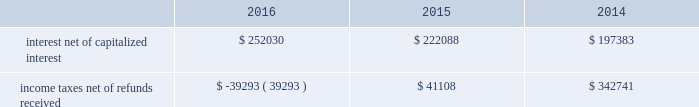The diluted earnings per share calculation excludes stock options , sars , restricted stock and units and performance units and stock that were anti-dilutive .
Shares underlying the excluded stock options and sars totaled 10.3 million , 10.2 million and 0.7 million for the years ended december 31 , 2016 , 2015 and 2014 , respectively .
For the years ended december 31 , 2016 and 2015 , respectively , 4.5 million and 5.3 million shares of restricted stock and restricted stock units and performance units and performance stock were excluded .
10 .
Supplemental cash flow information net cash paid for interest and income taxes was as follows for the years ended december 31 , 2016 , 2015 and 2014 ( in thousands ) : .
Eog's accrued capital expenditures at december 31 , 2016 , 2015 and 2014 were $ 388 million , $ 416 million and $ 972 million , respectively .
Non-cash investing activities for the year ended december 31 , 2016 , included $ 3834 million in non-cash additions to eog's oil and gas properties related to the yates transaction ( see note 17 ) .
Non-cash investing activities for the year ended december 31 , 2014 included non-cash additions of $ 5 million to eog's oil and gas properties as a result of property exchanges .
11 .
Business segment information eog's operations are all crude oil and natural gas exploration and production related .
The segment reporting topic of the asc establishes standards for reporting information about operating segments in annual financial statements .
Operating segments are defined as components of an enterprise about which separate financial information is available and evaluated regularly by the chief operating decision maker , or decision-making group , in deciding how to allocate resources and in assessing performance .
Eog's chief operating decision-making process is informal and involves the chairman of the board and chief executive officer and other key officers .
This group routinely reviews and makes operating decisions related to significant issues associated with each of eog's major producing areas in the united states , trinidad , the united kingdom and china .
For segment reporting purposes , the chief operating decision maker considers the major united states producing areas to be one operating segment. .
Considering the years 2015-2016 , what is variation observed in the number of stocks that were excluded , in millions? 
Rationale: it is the difference between each year's number of excluded stocks .
Computations: (5.3 - 4.5)
Answer: 0.8. 